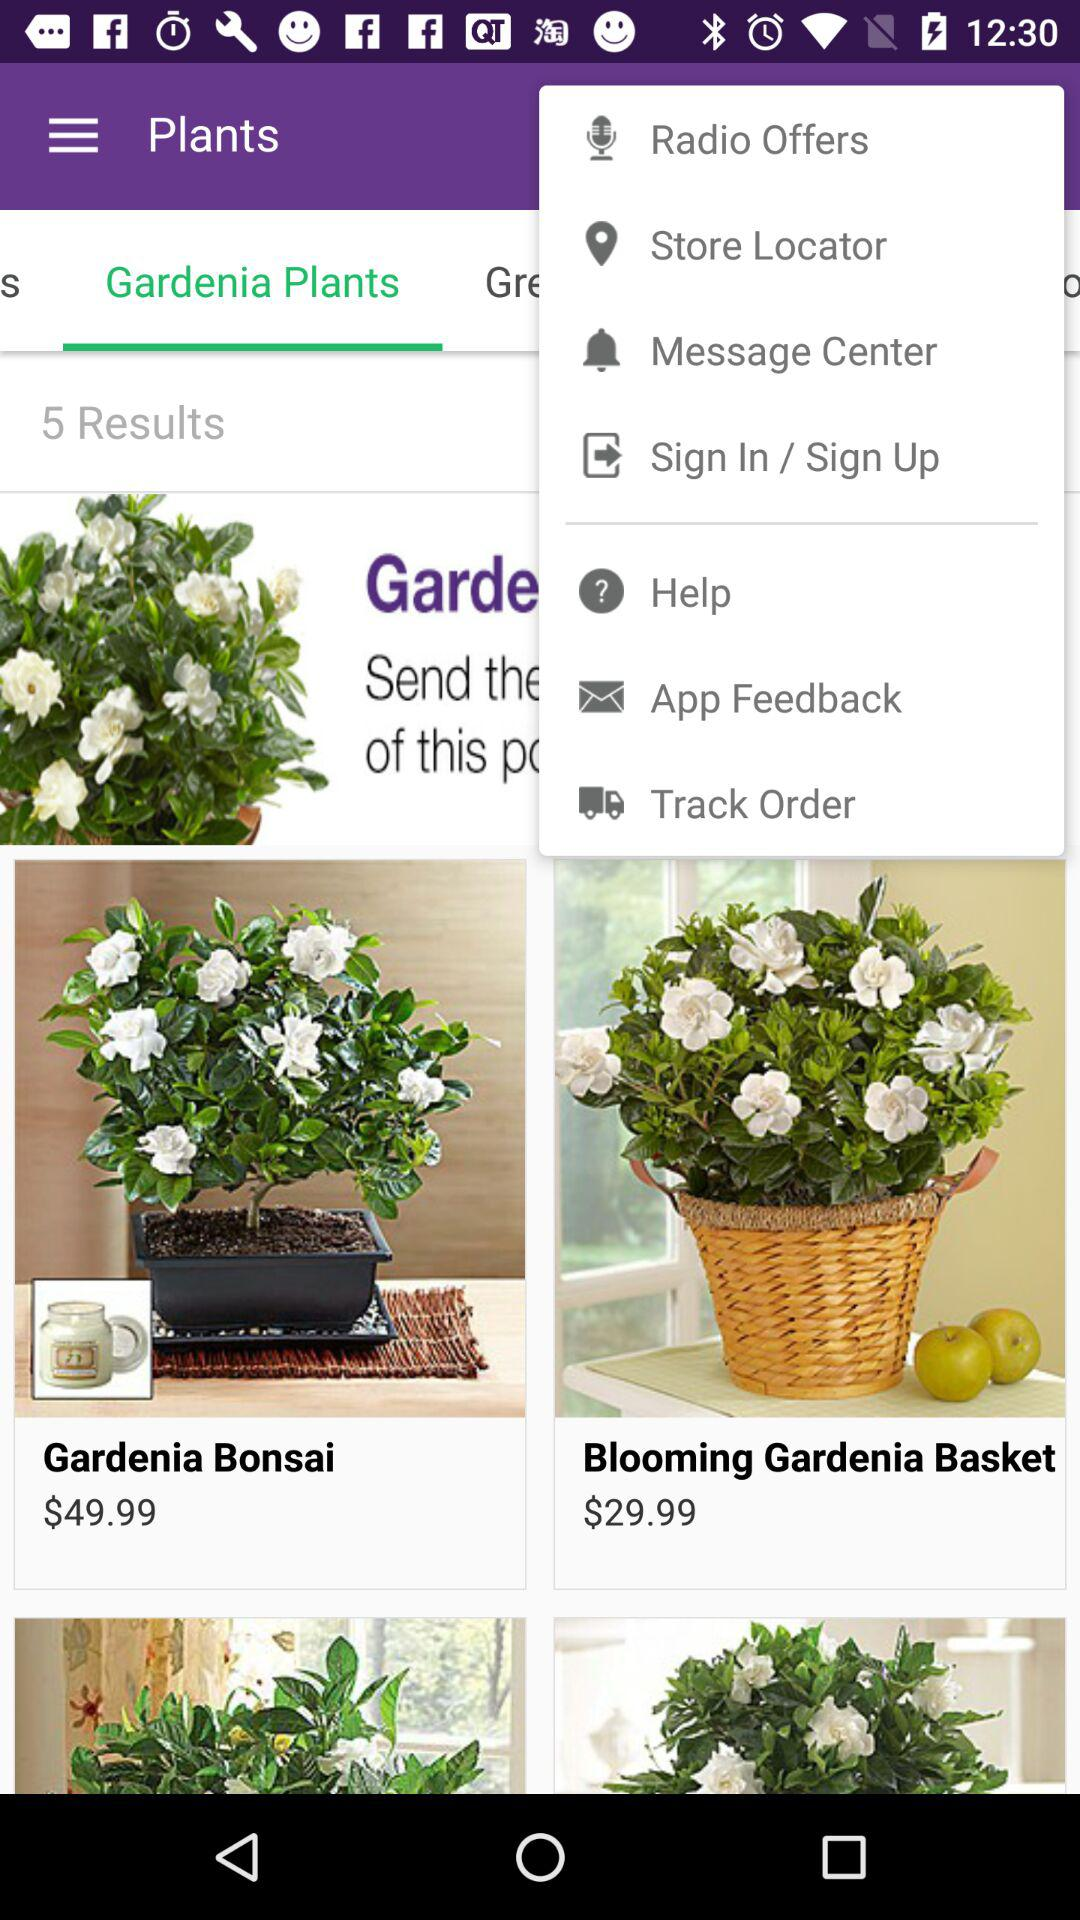Which option is selected in "Plants"? The selected option is "Gardenia Plants". 